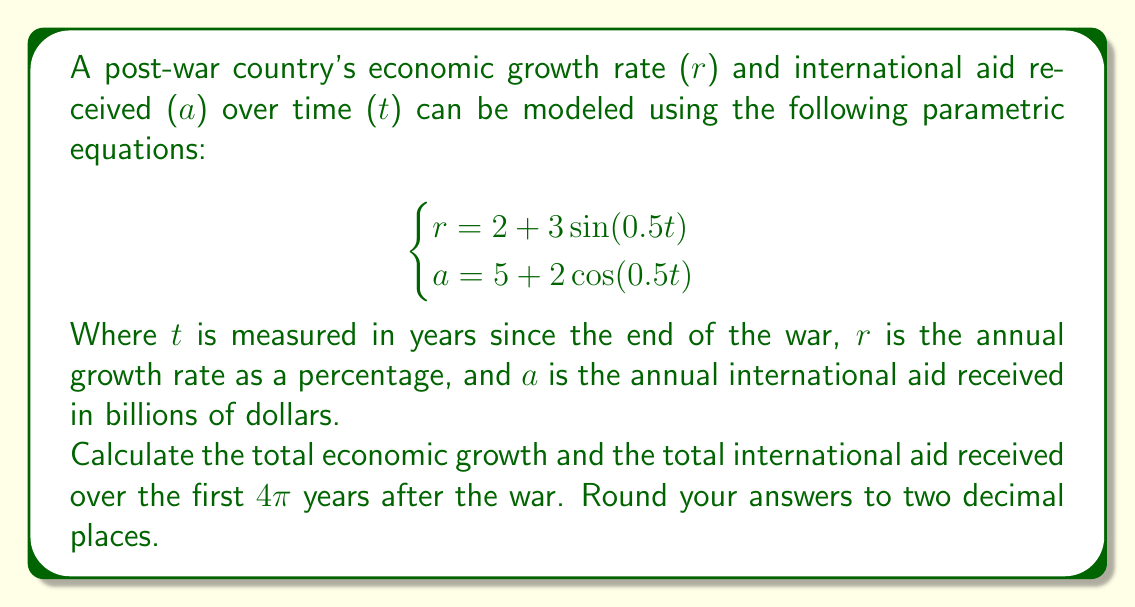Can you solve this math problem? To solve this problem, we need to integrate both equations over the given time period. Let's break it down step by step:

1. For the total economic growth:
   We need to integrate the growth rate equation over time.
   
   $$\int_0^{4\pi} (2 + 3\sin(0.5t)) dt$$

   Let u = 0.5t, then du = 0.5dt, or dt = 2du
   When t = 0, u = 0; when t = 4π, u = 2π

   $$2\int_0^{2\pi} (2 + 3\sin(u)) du$$
   
   $$= 2[2u - 3\cos(u)]_0^{2\pi}$$
   
   $$= 2[4\pi - 3\cos(2\pi) - (0 - 3\cos(0))]$$
   
   $$= 2[4\pi - 3 + 3] = 2[4\pi] = 8\pi$$

2. For the total international aid:
   We integrate the aid equation over time.
   
   $$\int_0^{4\pi} (5 + 2\cos(0.5t)) dt$$

   Using the same substitution as before:

   $$2\int_0^{2\pi} (5 + 2\cos(u)) du$$
   
   $$= 2[5u + 2\sin(u)]_0^{2\pi}$$
   
   $$= 2[10\pi + 2\sin(2\pi) - (0 + 2\sin(0))]$$
   
   $$= 2[10\pi] = 20\pi$$

3. Converting to decimal form and rounding to two decimal places:
   Total economic growth: 8π ≈ 25.13
   Total international aid: 20π ≈ 62.83
Answer: Total economic growth: 25.13%
Total international aid received: $62.83 billion 